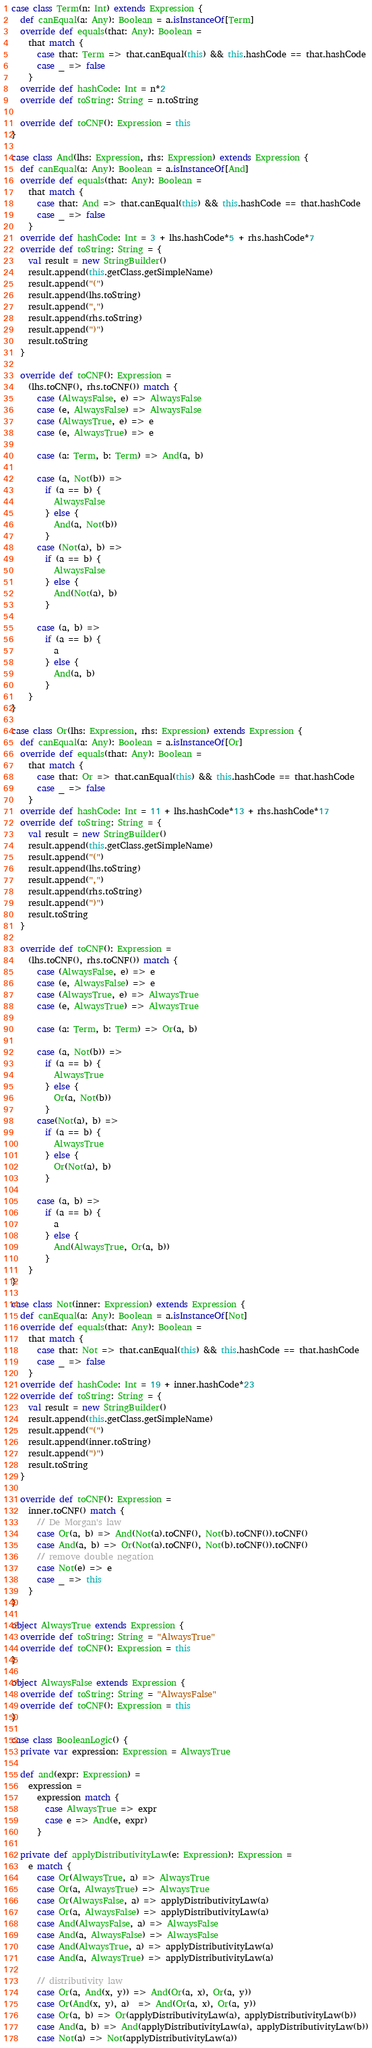<code> <loc_0><loc_0><loc_500><loc_500><_Scala_>
case class Term(n: Int) extends Expression {
  def canEqual(a: Any): Boolean = a.isInstanceOf[Term]
  override def equals(that: Any): Boolean =
    that match {
      case that: Term => that.canEqual(this) && this.hashCode == that.hashCode
      case _ => false
    }
  override def hashCode: Int = n*2
  override def toString: String = n.toString

  override def toCNF(): Expression = this
}

case class And(lhs: Expression, rhs: Expression) extends Expression {
  def canEqual(a: Any): Boolean = a.isInstanceOf[And]
  override def equals(that: Any): Boolean =
    that match {
      case that: And => that.canEqual(this) && this.hashCode == that.hashCode
      case _ => false
    }
  override def hashCode: Int = 3 + lhs.hashCode*5 + rhs.hashCode*7
  override def toString: String = {
    val result = new StringBuilder()
    result.append(this.getClass.getSimpleName)
    result.append("(")
    result.append(lhs.toString)
    result.append(",")
    result.append(rhs.toString)
    result.append(")")
    result.toString
  }

  override def toCNF(): Expression =
    (lhs.toCNF(), rhs.toCNF()) match {
      case (AlwaysFalse, e) => AlwaysFalse
      case (e, AlwaysFalse) => AlwaysFalse
      case (AlwaysTrue, e) => e
      case (e, AlwaysTrue) => e

      case (a: Term, b: Term) => And(a, b)

      case (a, Not(b)) =>
        if (a == b) {
          AlwaysFalse
        } else {
          And(a, Not(b))
        }
      case (Not(a), b) =>
        if (a == b) {
          AlwaysFalse
        } else {
          And(Not(a), b)
        }

      case (a, b) =>
        if (a == b) {
          a
        } else {
          And(a, b)
        }
    }
}

case class Or(lhs: Expression, rhs: Expression) extends Expression {
  def canEqual(a: Any): Boolean = a.isInstanceOf[Or]
  override def equals(that: Any): Boolean =
    that match {
      case that: Or => that.canEqual(this) && this.hashCode == that.hashCode
      case _ => false
    }
  override def hashCode: Int = 11 + lhs.hashCode*13 + rhs.hashCode*17
  override def toString: String = {
    val result = new StringBuilder()
    result.append(this.getClass.getSimpleName)
    result.append("(")
    result.append(lhs.toString)
    result.append(",")
    result.append(rhs.toString)
    result.append(")")
    result.toString
  }

  override def toCNF(): Expression =
    (lhs.toCNF(), rhs.toCNF()) match {
      case (AlwaysFalse, e) => e
      case (e, AlwaysFalse) => e
      case (AlwaysTrue, e) => AlwaysTrue
      case (e, AlwaysTrue) => AlwaysTrue

      case (a: Term, b: Term) => Or(a, b)

      case (a, Not(b)) =>
        if (a == b) {
          AlwaysTrue
        } else {
          Or(a, Not(b))
        }
      case(Not(a), b) =>
        if (a == b) {
          AlwaysTrue
        } else {
          Or(Not(a), b)
        }

      case (a, b) =>
        if (a == b) {
          a
        } else {
          And(AlwaysTrue, Or(a, b))
        }
    }
}

case class Not(inner: Expression) extends Expression {
  def canEqual(a: Any): Boolean = a.isInstanceOf[Not]
  override def equals(that: Any): Boolean =
    that match {
      case that: Not => that.canEqual(this) && this.hashCode == that.hashCode
      case _ => false
    }
  override def hashCode: Int = 19 + inner.hashCode*23
  override def toString: String = {
    val result = new StringBuilder()
    result.append(this.getClass.getSimpleName)
    result.append("(")
    result.append(inner.toString)
    result.append(")")
    result.toString
  }

  override def toCNF(): Expression =
    inner.toCNF() match {
      // De Morgan's law
      case Or(a, b) => And(Not(a).toCNF(), Not(b).toCNF()).toCNF()
      case And(a, b) => Or(Not(a).toCNF(), Not(b).toCNF()).toCNF()
      // remove double negation
      case Not(e) => e
      case _ => this
    }
}

object AlwaysTrue extends Expression {
  override def toString: String = "AlwaysTrue"
  override def toCNF(): Expression = this
}

object AlwaysFalse extends Expression {
  override def toString: String = "AlwaysFalse"
  override def toCNF(): Expression = this
}

case class BooleanLogic() {
  private var expression: Expression = AlwaysTrue

  def and(expr: Expression) =
    expression =
      expression match {
        case AlwaysTrue => expr
        case e => And(e, expr)
      }

  private def applyDistributivityLaw(e: Expression): Expression =
    e match {
      case Or(AlwaysTrue, a) => AlwaysTrue
      case Or(a, AlwaysTrue) => AlwaysTrue
      case Or(AlwaysFalse, a) => applyDistributivityLaw(a)
      case Or(a, AlwaysFalse) => applyDistributivityLaw(a)
      case And(AlwaysFalse, a) => AlwaysFalse
      case And(a, AlwaysFalse) => AlwaysFalse
      case And(AlwaysTrue, a) => applyDistributivityLaw(a)
      case And(a, AlwaysTrue) => applyDistributivityLaw(a)

      // distributivity law
      case Or(a, And(x, y)) => And(Or(a, x), Or(a, y))
      case Or(And(x, y), a)  => And(Or(a, x), Or(a, y))
      case Or(a, b) => Or(applyDistributivityLaw(a), applyDistributivityLaw(b))
      case And(a, b) => And(applyDistributivityLaw(a), applyDistributivityLaw(b))
      case Not(a) => Not(applyDistributivityLaw(a))</code> 